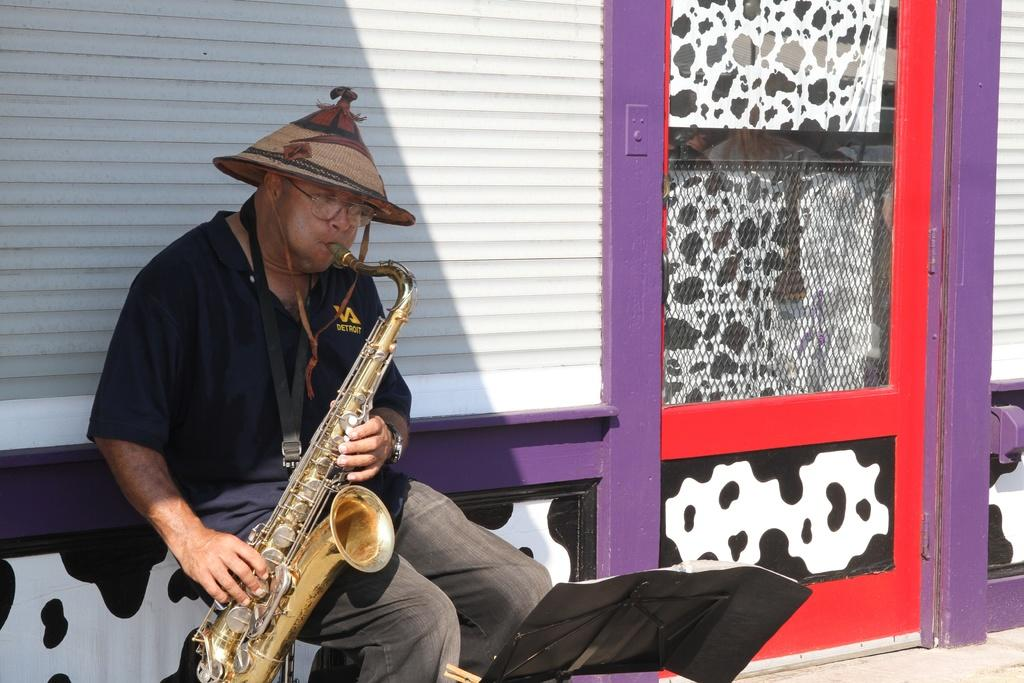What is the man in the image doing? The man is playing a saxophone. What object is placed before the man? There is a book placed on a stand before the man. What can be seen in the background of the image? There is a wall and a door visible in the background of the image. What type of clouds can be seen in the image? There are no clouds visible in the image; it features a man playing a saxophone with a book on a stand and a wall and door in the background. 